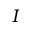<formula> <loc_0><loc_0><loc_500><loc_500>I</formula> 